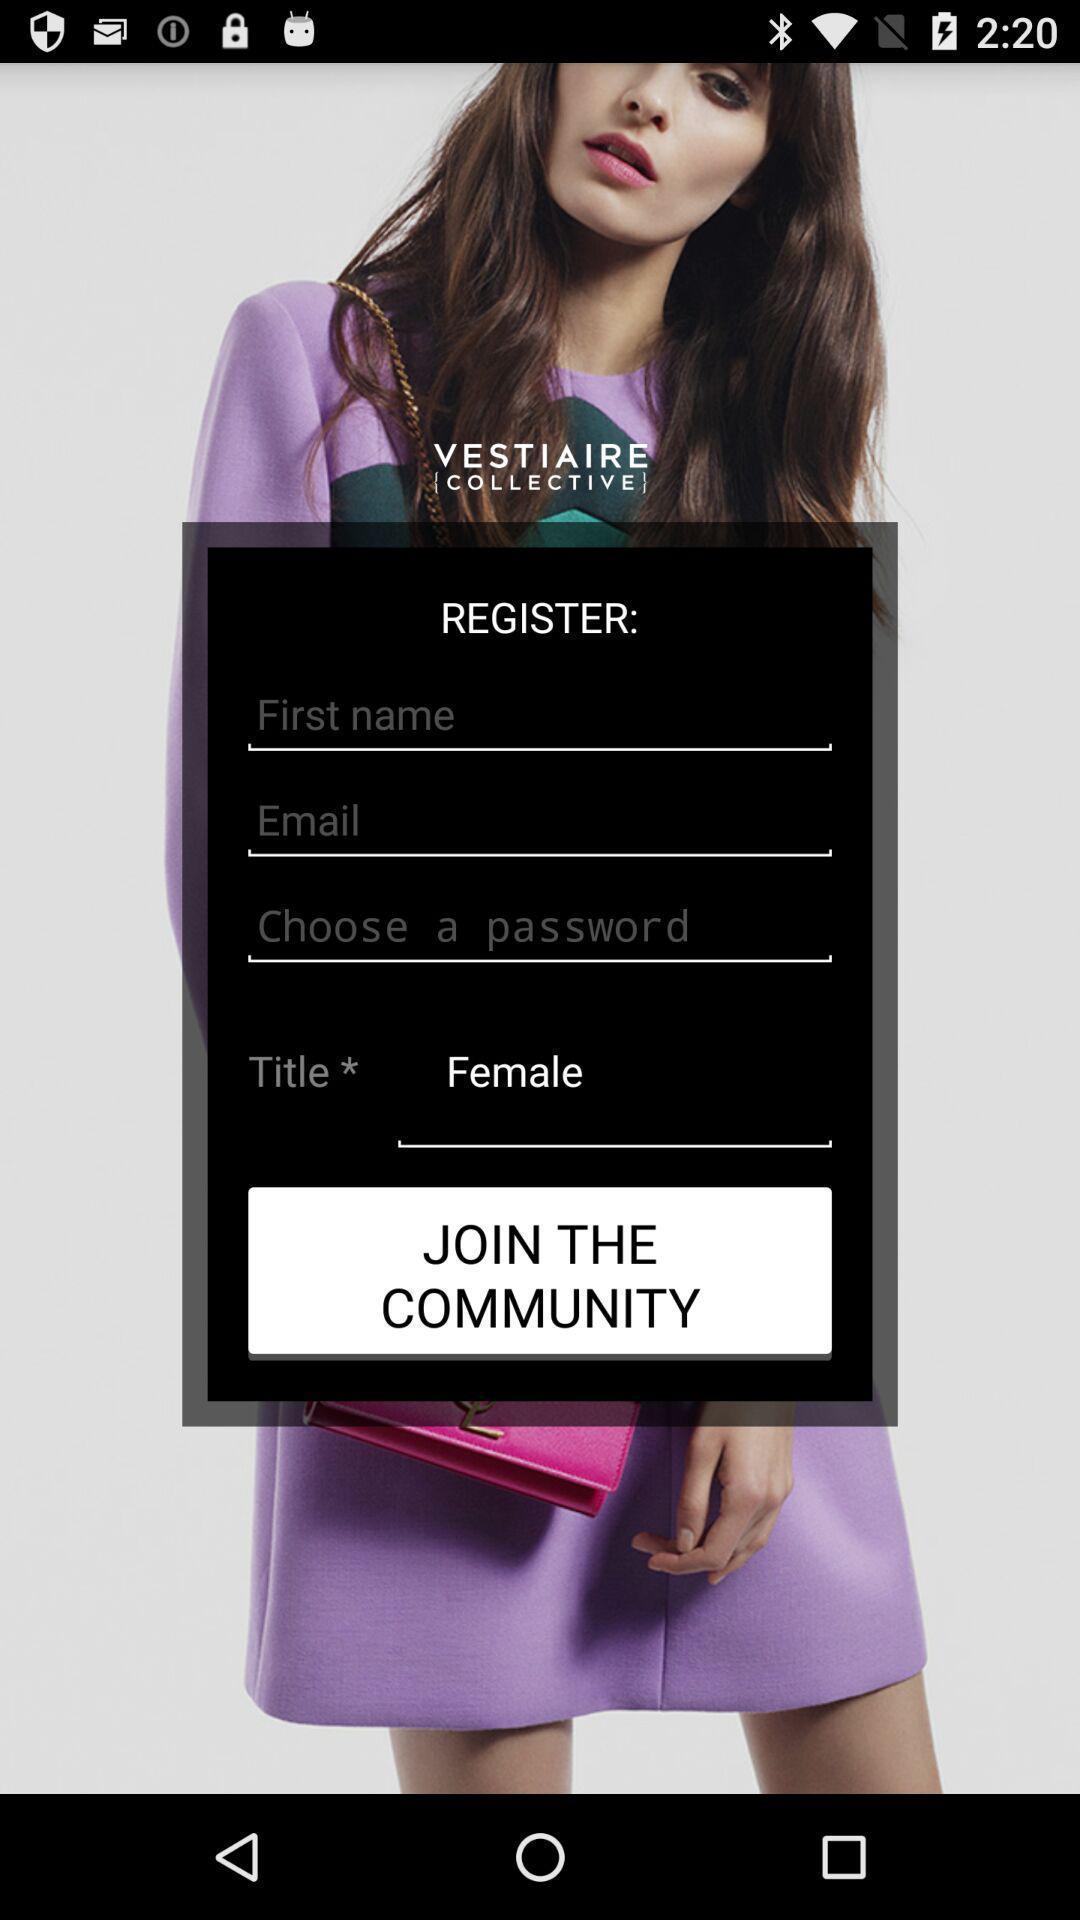Provide a description of this screenshot. Sign in page of a shopping app. 